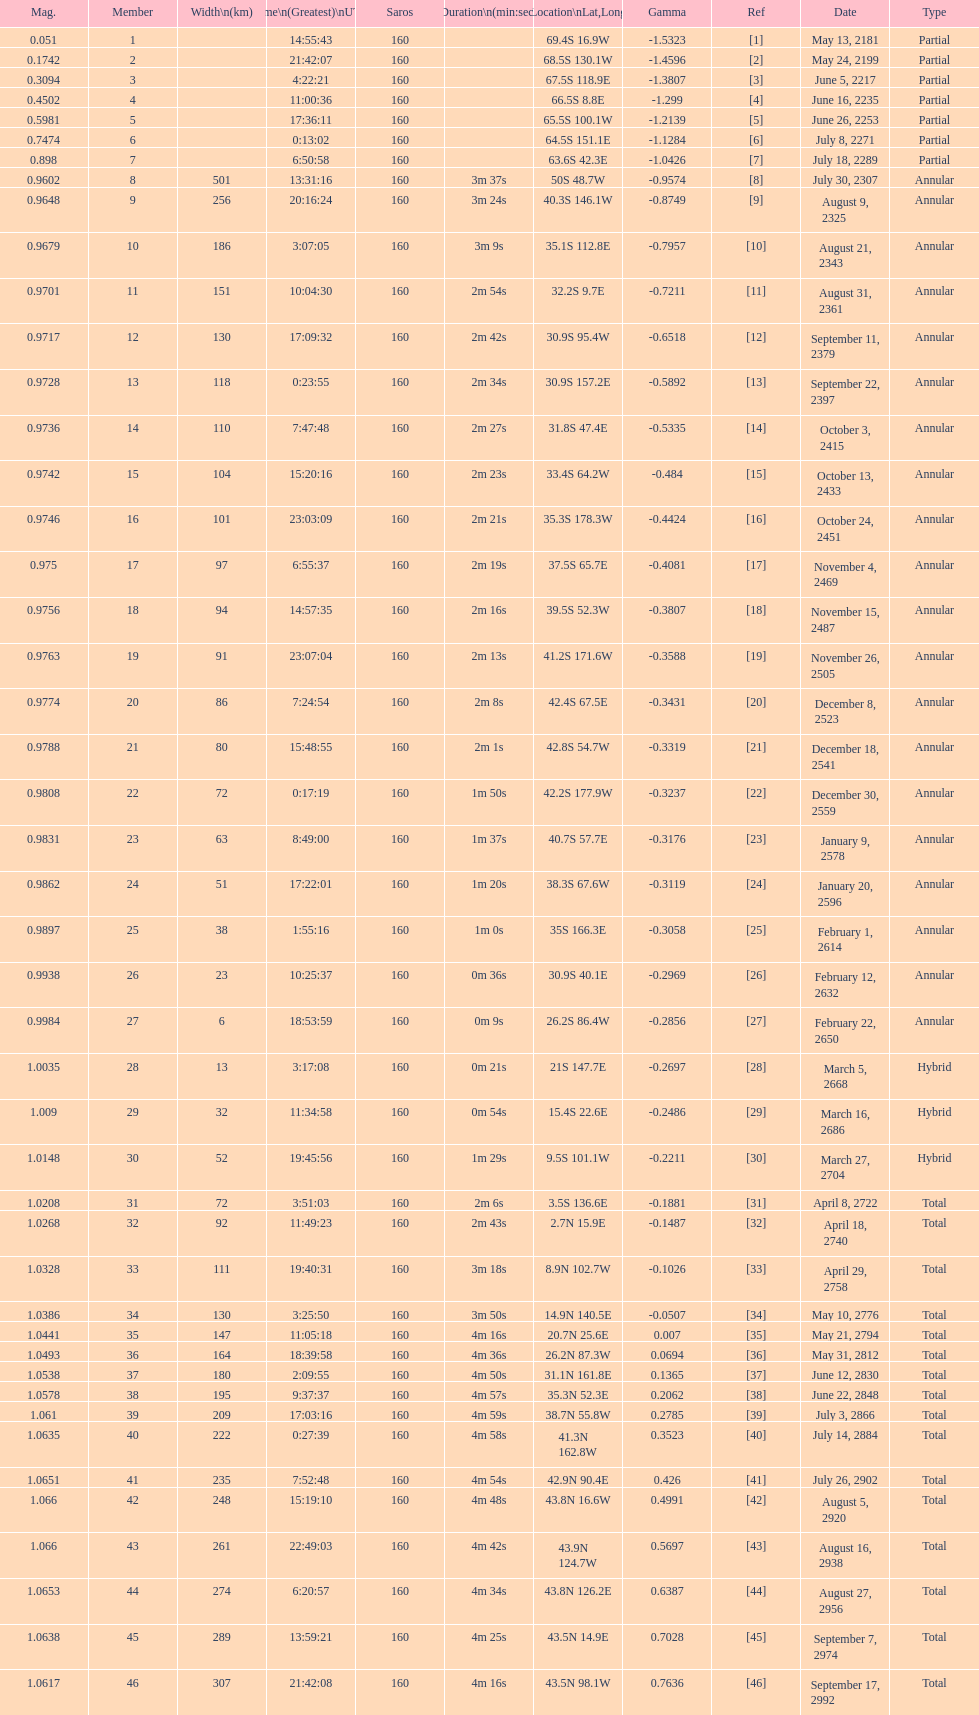When did the first solar saros with a magnitude of greater than 1.00 occur? March 5, 2668. 